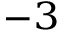Convert formula to latex. <formula><loc_0><loc_0><loc_500><loc_500>^ { - 3 }</formula> 